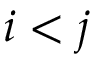<formula> <loc_0><loc_0><loc_500><loc_500>i < j</formula> 